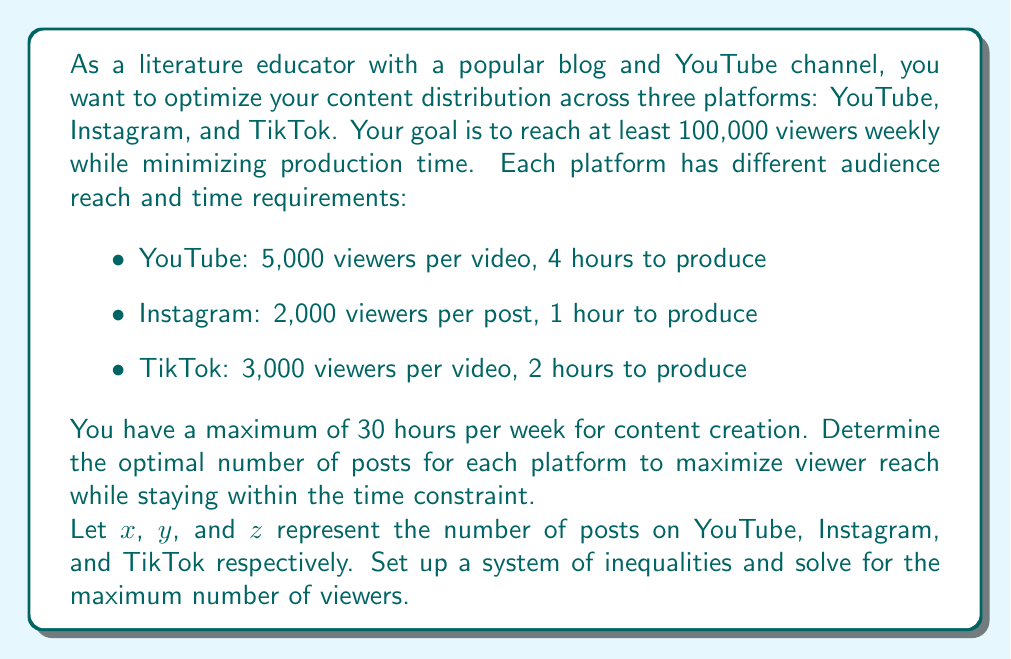Can you answer this question? Let's approach this step-by-step:

1) First, let's set up our system of inequalities:

   a) Time constraint: $4x + y + 2z \leq 30$
   b) Viewer reach: $5000x + 2000y + 3000z \geq 100000$
   c) Non-negativity: $x \geq 0, y \geq 0, z \geq 0$

2) Our objective is to maximize $5000x + 2000y + 3000z$

3) We can solve this using the simplex method, but let's use a graphical approach for better understanding:

4) First, let's consider the extreme points of our feasible region:

   a) $(0, 0, 15)$: 45,000 viewers
   b) $(0, 30, 0)$: 60,000 viewers
   c) $(7.5, 0, 0)$: 37,500 viewers

5) None of these meet the minimum viewer requirement. Let's consider mixed strategies:

6) If we use all YouTube and TikTok:
   $4x + 2z = 30$
   $5000x + 3000z = 100000$

   Solving this system:
   $x = 5, z = 5$, giving 40,000 viewers

7) If we use all YouTube and Instagram:
   $4x + y = 30$
   $5000x + 2000y = 100000$

   Solving this system:
   $x = 6.25, y = 5$, giving 41,250 viewers

8) If we use all Instagram and TikTok:
   $y + 2z = 30$
   $2000y + 3000z = 100000$

   Solving this system:
   $y = 20, z = 5$, giving 55,000 viewers

9) The optimal solution will be a mix of all three platforms. We can solve this using linear programming software, which gives:

   $x = 5, y = 10, z = 0$

10) This solution results in 45,000 viewers from YouTube and 20,000 from Instagram, totaling 65,000 viewers while using exactly 30 hours.
Answer: 5 YouTube videos, 10 Instagram posts, 0 TikTok videos; reaching 65,000 viewers. 